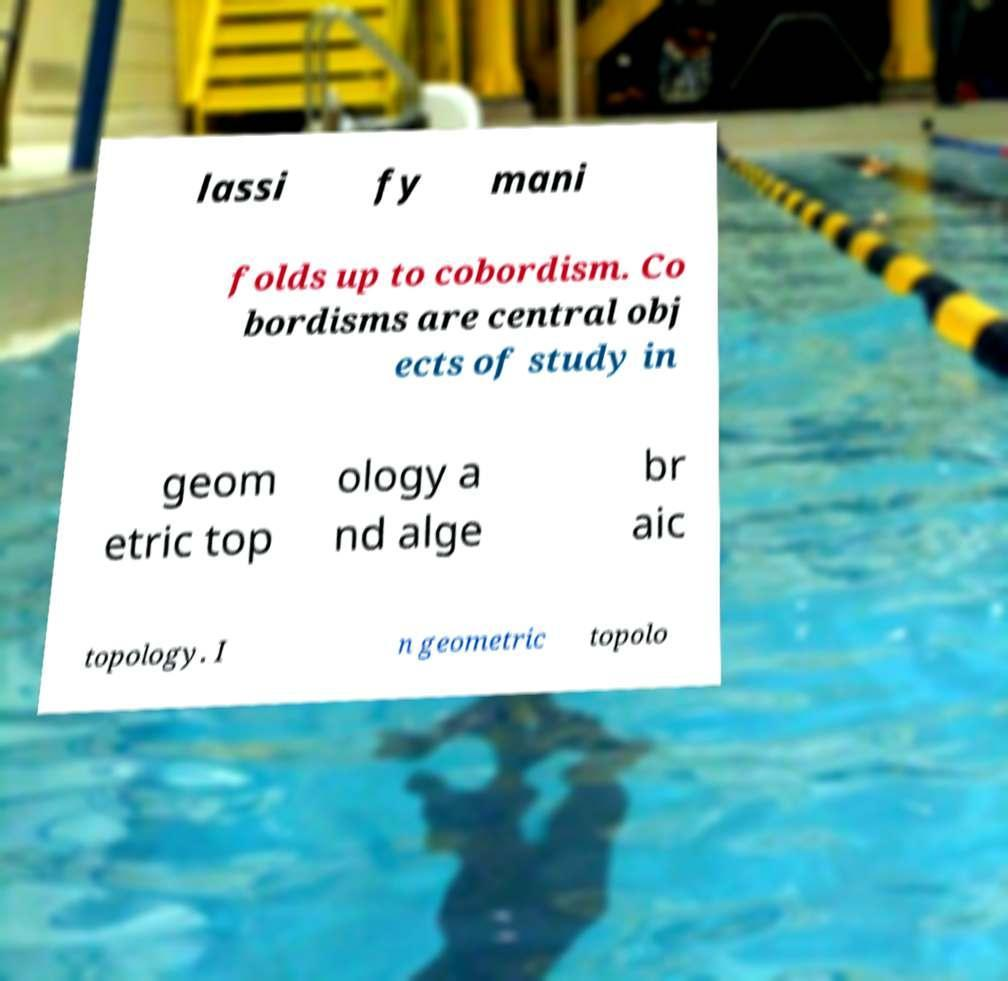Can you read and provide the text displayed in the image?This photo seems to have some interesting text. Can you extract and type it out for me? lassi fy mani folds up to cobordism. Co bordisms are central obj ects of study in geom etric top ology a nd alge br aic topology. I n geometric topolo 